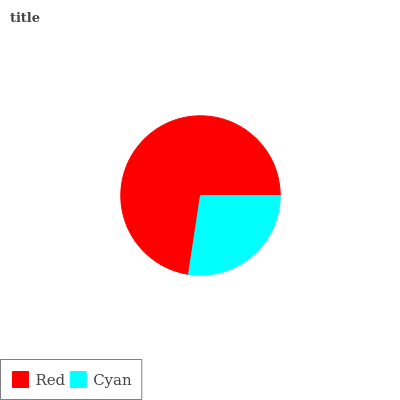Is Cyan the minimum?
Answer yes or no. Yes. Is Red the maximum?
Answer yes or no. Yes. Is Cyan the maximum?
Answer yes or no. No. Is Red greater than Cyan?
Answer yes or no. Yes. Is Cyan less than Red?
Answer yes or no. Yes. Is Cyan greater than Red?
Answer yes or no. No. Is Red less than Cyan?
Answer yes or no. No. Is Red the high median?
Answer yes or no. Yes. Is Cyan the low median?
Answer yes or no. Yes. Is Cyan the high median?
Answer yes or no. No. Is Red the low median?
Answer yes or no. No. 